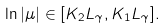<formula> <loc_0><loc_0><loc_500><loc_500>\ln | \mu | \in [ K _ { 2 } L _ { \gamma } , K _ { 1 } L _ { \gamma } ] .</formula> 